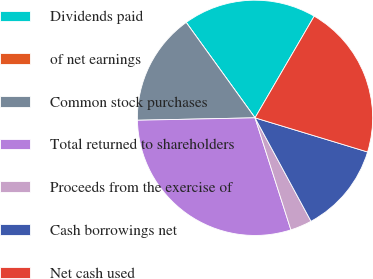Convert chart. <chart><loc_0><loc_0><loc_500><loc_500><pie_chart><fcel>Dividends paid<fcel>of net earnings<fcel>Common stock purchases<fcel>Total returned to shareholders<fcel>Proceeds from the exercise of<fcel>Cash borrowings net<fcel>Net cash used<nl><fcel>18.34%<fcel>0.0%<fcel>15.38%<fcel>29.61%<fcel>2.96%<fcel>12.42%<fcel>21.3%<nl></chart> 